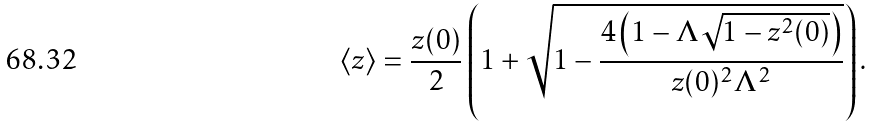<formula> <loc_0><loc_0><loc_500><loc_500>\left \langle z \right \rangle = \frac { z ( 0 ) } 2 \left ( 1 + \sqrt { 1 - \frac { 4 \left ( 1 - \Lambda \sqrt { 1 - z ^ { 2 } ( 0 ) } \right ) } { z ( 0 ) ^ { 2 } \Lambda ^ { 2 } } } \right ) .</formula> 